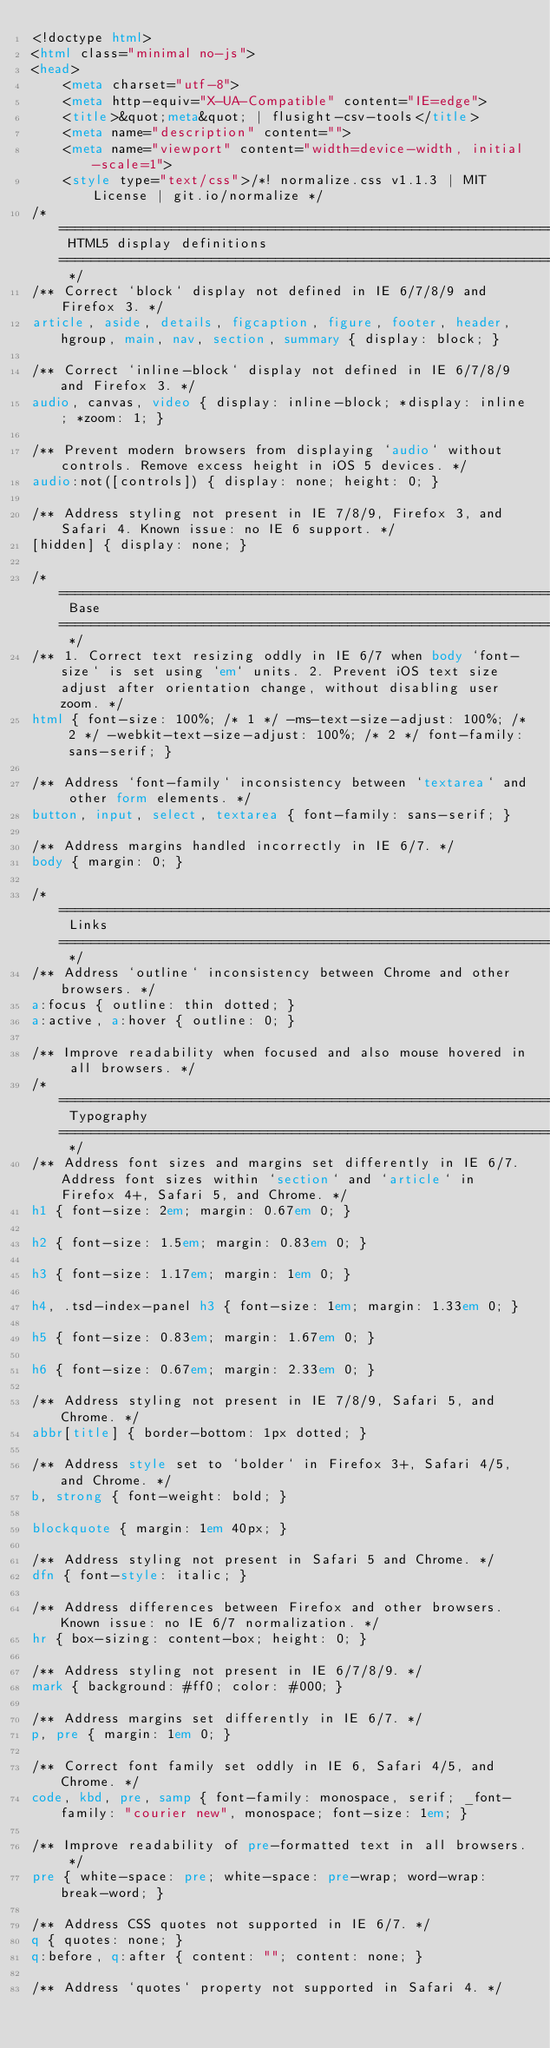<code> <loc_0><loc_0><loc_500><loc_500><_HTML_><!doctype html>
<html class="minimal no-js">
<head>
	<meta charset="utf-8">
	<meta http-equiv="X-UA-Compatible" content="IE=edge">
	<title>&quot;meta&quot; | flusight-csv-tools</title>
	<meta name="description" content="">
	<meta name="viewport" content="width=device-width, initial-scale=1">
	<style type="text/css">/*! normalize.css v1.1.3 | MIT License | git.io/normalize */
/* ========================================================================== HTML5 display definitions ========================================================================== */
/** Correct `block` display not defined in IE 6/7/8/9 and Firefox 3. */
article, aside, details, figcaption, figure, footer, header, hgroup, main, nav, section, summary { display: block; }

/** Correct `inline-block` display not defined in IE 6/7/8/9 and Firefox 3. */
audio, canvas, video { display: inline-block; *display: inline; *zoom: 1; }

/** Prevent modern browsers from displaying `audio` without controls. Remove excess height in iOS 5 devices. */
audio:not([controls]) { display: none; height: 0; }

/** Address styling not present in IE 7/8/9, Firefox 3, and Safari 4. Known issue: no IE 6 support. */
[hidden] { display: none; }

/* ========================================================================== Base ========================================================================== */
/** 1. Correct text resizing oddly in IE 6/7 when body `font-size` is set using `em` units. 2. Prevent iOS text size adjust after orientation change, without disabling user zoom. */
html { font-size: 100%; /* 1 */ -ms-text-size-adjust: 100%; /* 2 */ -webkit-text-size-adjust: 100%; /* 2 */ font-family: sans-serif; }

/** Address `font-family` inconsistency between `textarea` and other form elements. */
button, input, select, textarea { font-family: sans-serif; }

/** Address margins handled incorrectly in IE 6/7. */
body { margin: 0; }

/* ========================================================================== Links ========================================================================== */
/** Address `outline` inconsistency between Chrome and other browsers. */
a:focus { outline: thin dotted; }
a:active, a:hover { outline: 0; }

/** Improve readability when focused and also mouse hovered in all browsers. */
/* ========================================================================== Typography ========================================================================== */
/** Address font sizes and margins set differently in IE 6/7. Address font sizes within `section` and `article` in Firefox 4+, Safari 5, and Chrome. */
h1 { font-size: 2em; margin: 0.67em 0; }

h2 { font-size: 1.5em; margin: 0.83em 0; }

h3 { font-size: 1.17em; margin: 1em 0; }

h4, .tsd-index-panel h3 { font-size: 1em; margin: 1.33em 0; }

h5 { font-size: 0.83em; margin: 1.67em 0; }

h6 { font-size: 0.67em; margin: 2.33em 0; }

/** Address styling not present in IE 7/8/9, Safari 5, and Chrome. */
abbr[title] { border-bottom: 1px dotted; }

/** Address style set to `bolder` in Firefox 3+, Safari 4/5, and Chrome. */
b, strong { font-weight: bold; }

blockquote { margin: 1em 40px; }

/** Address styling not present in Safari 5 and Chrome. */
dfn { font-style: italic; }

/** Address differences between Firefox and other browsers. Known issue: no IE 6/7 normalization. */
hr { box-sizing: content-box; height: 0; }

/** Address styling not present in IE 6/7/8/9. */
mark { background: #ff0; color: #000; }

/** Address margins set differently in IE 6/7. */
p, pre { margin: 1em 0; }

/** Correct font family set oddly in IE 6, Safari 4/5, and Chrome. */
code, kbd, pre, samp { font-family: monospace, serif; _font-family: "courier new", monospace; font-size: 1em; }

/** Improve readability of pre-formatted text in all browsers. */
pre { white-space: pre; white-space: pre-wrap; word-wrap: break-word; }

/** Address CSS quotes not supported in IE 6/7. */
q { quotes: none; }
q:before, q:after { content: ""; content: none; }

/** Address `quotes` property not supported in Safari 4. */</code> 